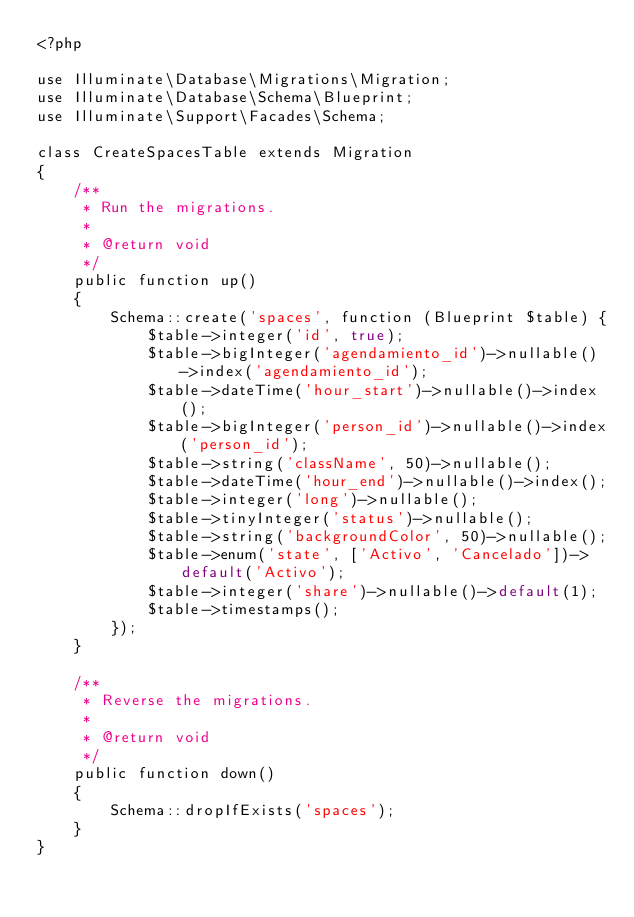<code> <loc_0><loc_0><loc_500><loc_500><_PHP_><?php

use Illuminate\Database\Migrations\Migration;
use Illuminate\Database\Schema\Blueprint;
use Illuminate\Support\Facades\Schema;

class CreateSpacesTable extends Migration
{
    /**
     * Run the migrations.
     *
     * @return void
     */
    public function up()
    {
        Schema::create('spaces', function (Blueprint $table) {
            $table->integer('id', true);
            $table->bigInteger('agendamiento_id')->nullable()->index('agendamiento_id');
            $table->dateTime('hour_start')->nullable()->index();
            $table->bigInteger('person_id')->nullable()->index('person_id');
            $table->string('className', 50)->nullable();
            $table->dateTime('hour_end')->nullable()->index();
            $table->integer('long')->nullable();
            $table->tinyInteger('status')->nullable();
            $table->string('backgroundColor', 50)->nullable();
            $table->enum('state', ['Activo', 'Cancelado'])->default('Activo');
            $table->integer('share')->nullable()->default(1);
            $table->timestamps();
        });
    }

    /**
     * Reverse the migrations.
     *
     * @return void
     */
    public function down()
    {
        Schema::dropIfExists('spaces');
    }
}
</code> 